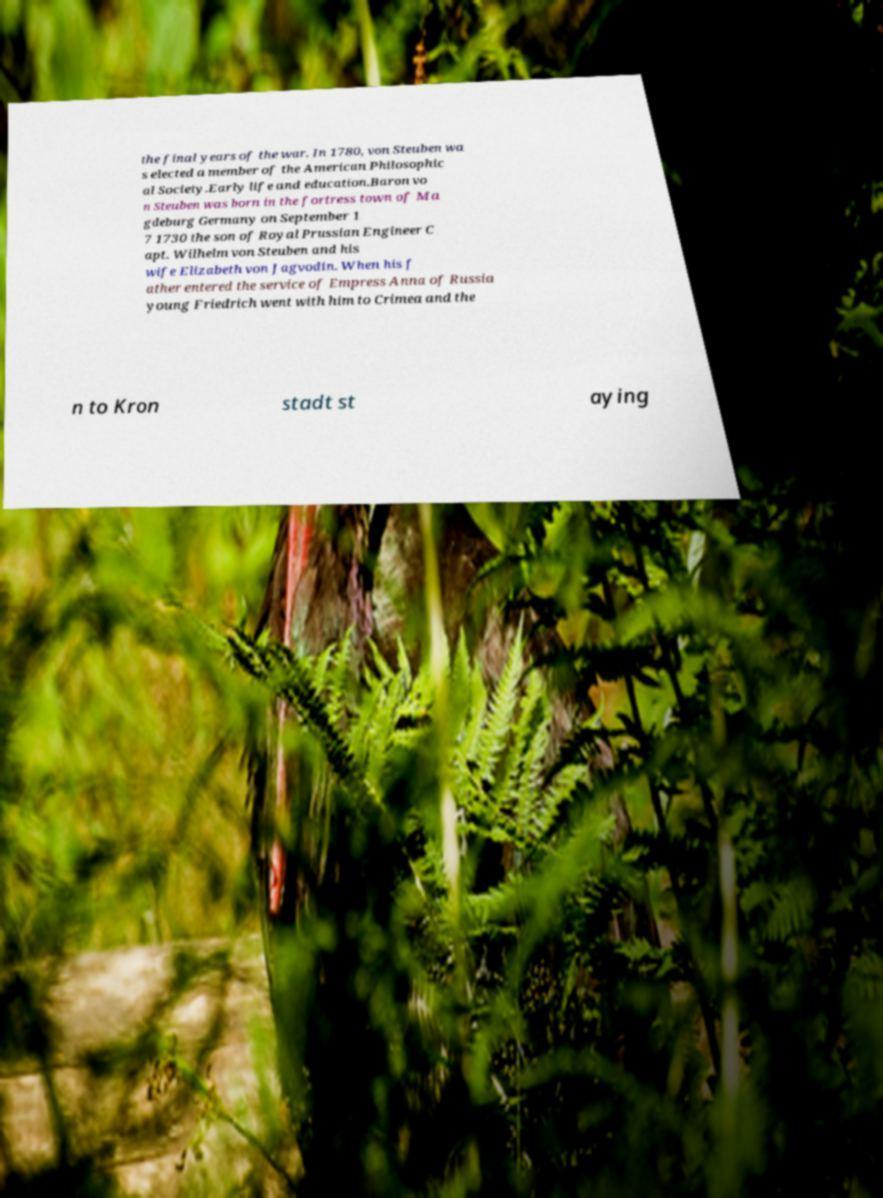Please read and relay the text visible in this image. What does it say? the final years of the war. In 1780, von Steuben wa s elected a member of the American Philosophic al Society.Early life and education.Baron vo n Steuben was born in the fortress town of Ma gdeburg Germany on September 1 7 1730 the son of Royal Prussian Engineer C apt. Wilhelm von Steuben and his wife Elizabeth von Jagvodin. When his f ather entered the service of Empress Anna of Russia young Friedrich went with him to Crimea and the n to Kron stadt st aying 